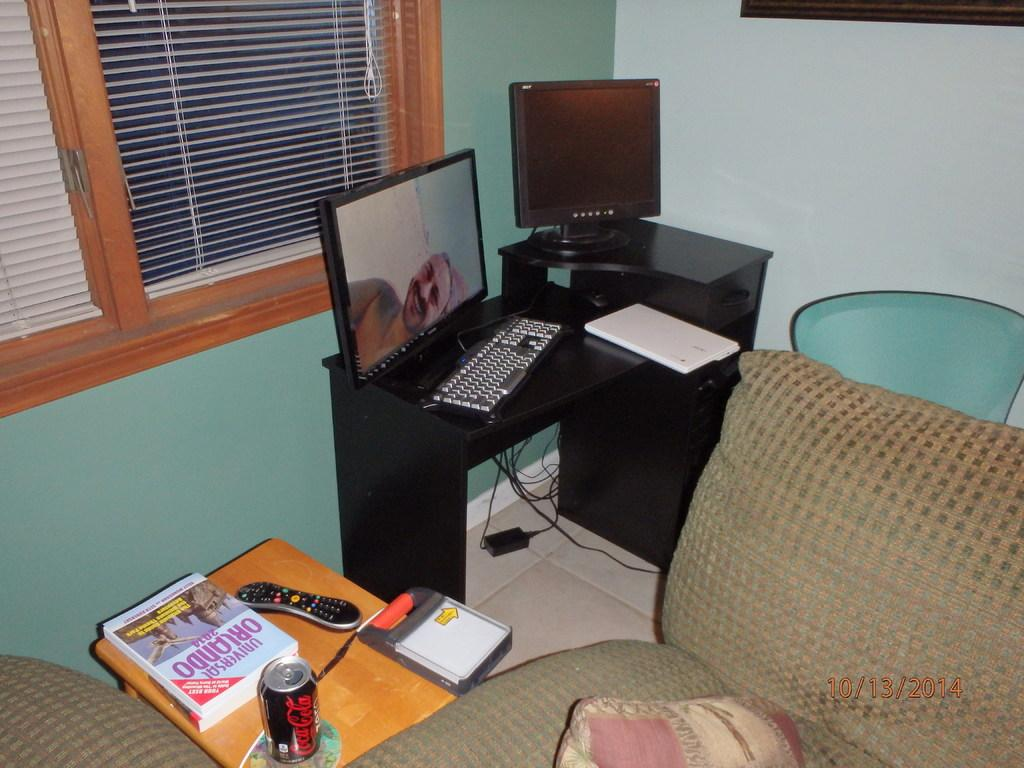What electronic device is on the table in the image? There is a computer on the table in the image. What is connected to the computer on the table? There is a monitor on the table. What object is on the stool in the image? There is a remote, a book, and a tin on the stool in the image. What type of furniture is in the room? There is a sofa in the room. What can be seen in the background of the image? There is a wall and a curtain in the background of the image. How many rings does the person in the image have on their fingers? There is no person visible in the image, so it is not possible to determine how many rings they might be wearing. 